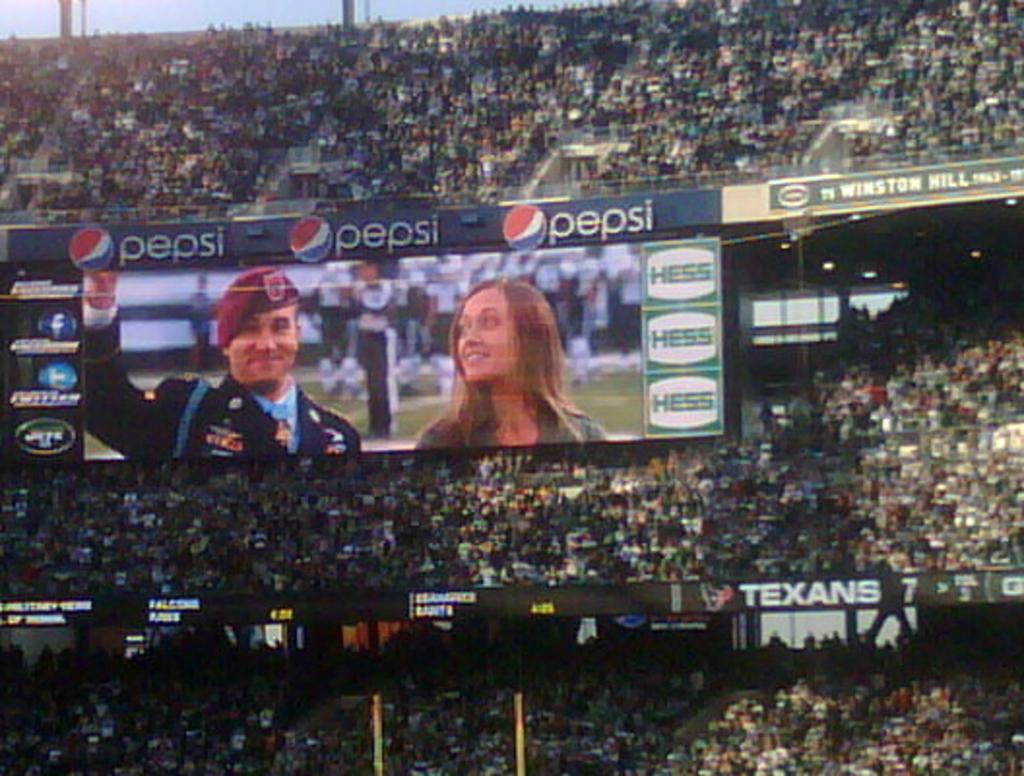What drink is being advertised?
Offer a terse response. Pepsi. What nfl team is on the banner near the bottom?
Your response must be concise. Texans. 